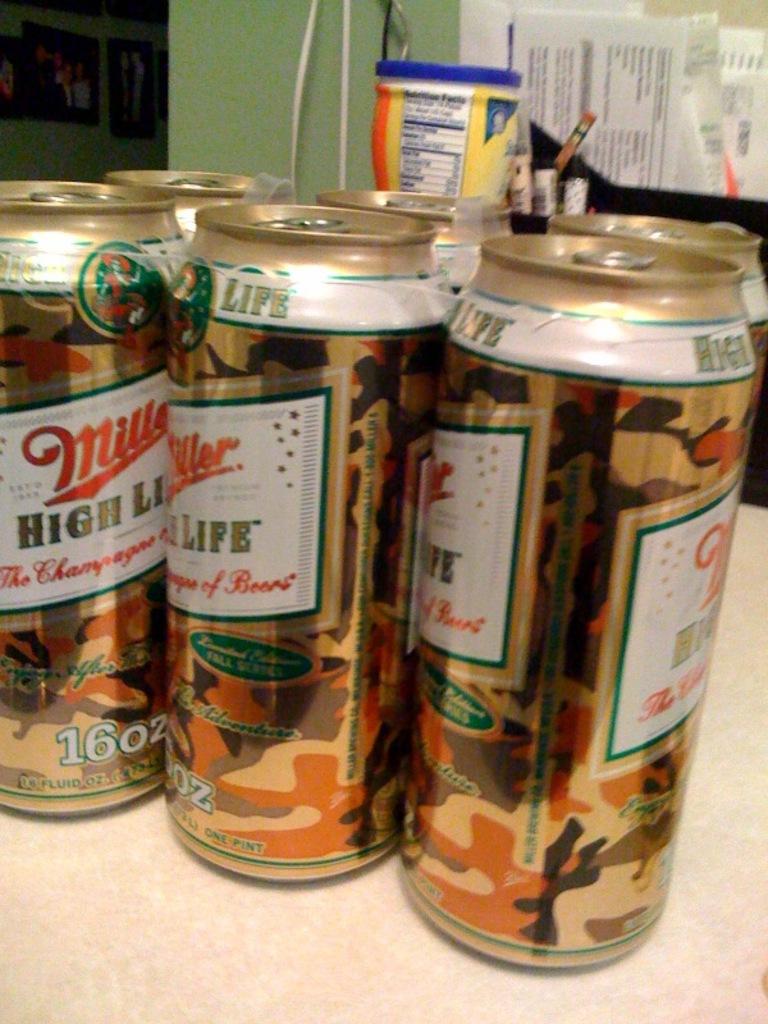How much liquid is in the can?
Ensure brevity in your answer.  16oz. What is name of beer?
Give a very brief answer. Miller high life. 